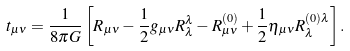Convert formula to latex. <formula><loc_0><loc_0><loc_500><loc_500>t _ { \mu \nu } = \frac { 1 } { 8 \pi G } \left [ R _ { \mu \nu } - \frac { 1 } { 2 } g _ { \mu \nu } R ^ { \lambda } _ { \lambda } - R ^ { ( 0 ) } _ { \mu \nu } + \frac { 1 } { 2 } \eta _ { \mu \nu } R ^ { ( 0 ) \lambda } _ { \lambda } \right ] .</formula> 